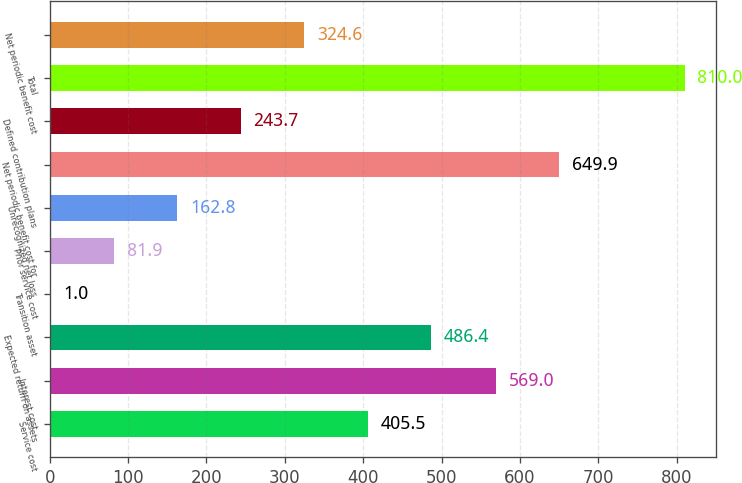Convert chart. <chart><loc_0><loc_0><loc_500><loc_500><bar_chart><fcel>Service cost<fcel>Interest cost<fcel>Expected return on assets<fcel>Transition asset<fcel>Prior service cost<fcel>Unrecognized net loss<fcel>Net periodic benefit cost for<fcel>Defined contribution plans<fcel>Total<fcel>Net periodic benefit cost<nl><fcel>405.5<fcel>569<fcel>486.4<fcel>1<fcel>81.9<fcel>162.8<fcel>649.9<fcel>243.7<fcel>810<fcel>324.6<nl></chart> 